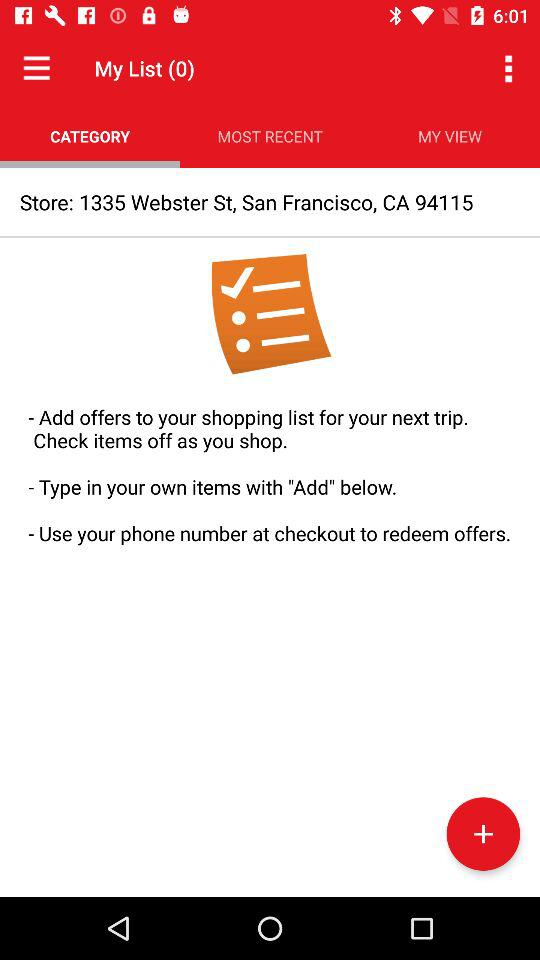Which tab is selected? The selected tab is "CATEGORY". 